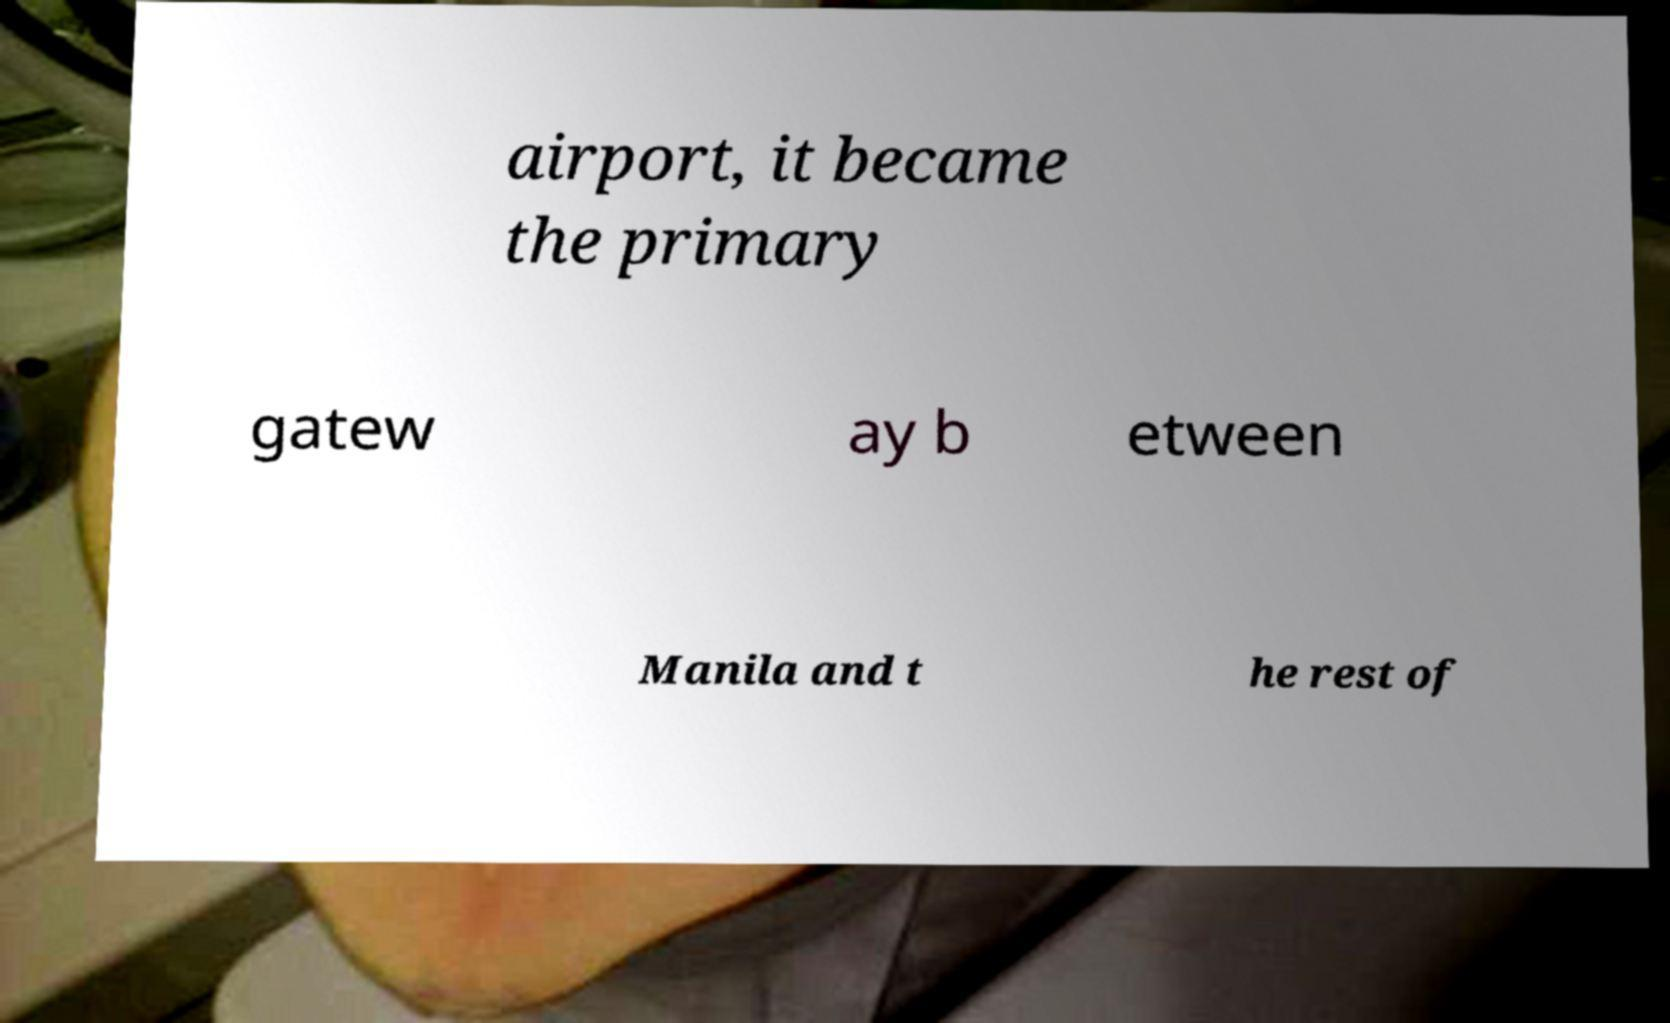There's text embedded in this image that I need extracted. Can you transcribe it verbatim? airport, it became the primary gatew ay b etween Manila and t he rest of 